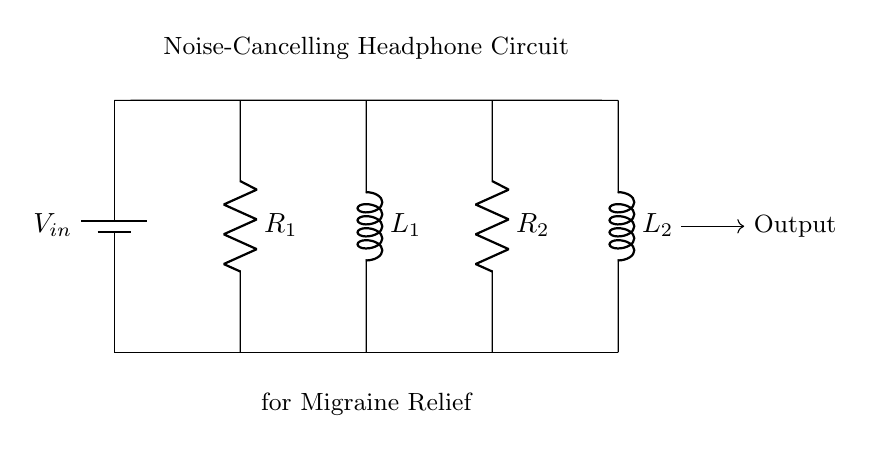What is the total number of components in the circuit? The circuit contains four main components: two resistors (R1 and R2) and two inductors (L1 and L2). Counting all components gives a total of four.
Answer: four What is the function of R1 in this circuit? R1 is used to limit the current flowing through the circuit. Its resistance contributes to the overall impedance, which affects the circuit's response to sound waves for noise cancellation.
Answer: limit current What is the role of L2 in noise-cancelling? L2 acts as an inductor to provide inductive reactance, which helps filter out unwanted frequency components, thus enhancing the noise-cancelling effect of the headphone.
Answer: filtering frequencies How many inductors are present in the circuit? The circuit features two inductors: L1 and L2. Each inductor helps with the phase adjustment of the audio signal to achieve noise cancellation. Counting these gives a total of two inductors.
Answer: two What is the relationship between R2 and L2 in this circuit? R2 and L2 form a part of a parallel or series circuit configuration. The combination adjusts the impedance and resonance frequency of the circuit, influencing how effectively it cancels noise. Their values together create a specific frequency response crucial for noise cancellation.
Answer: adjust impedance Which component connects the battery to the circuit? The circuit is connected to the battery through the upper wire leading from the battery (V_in). The voltage source (battery) powers the entire circuit, and the connection ensures that all components receive electrical energy.
Answer: battery 